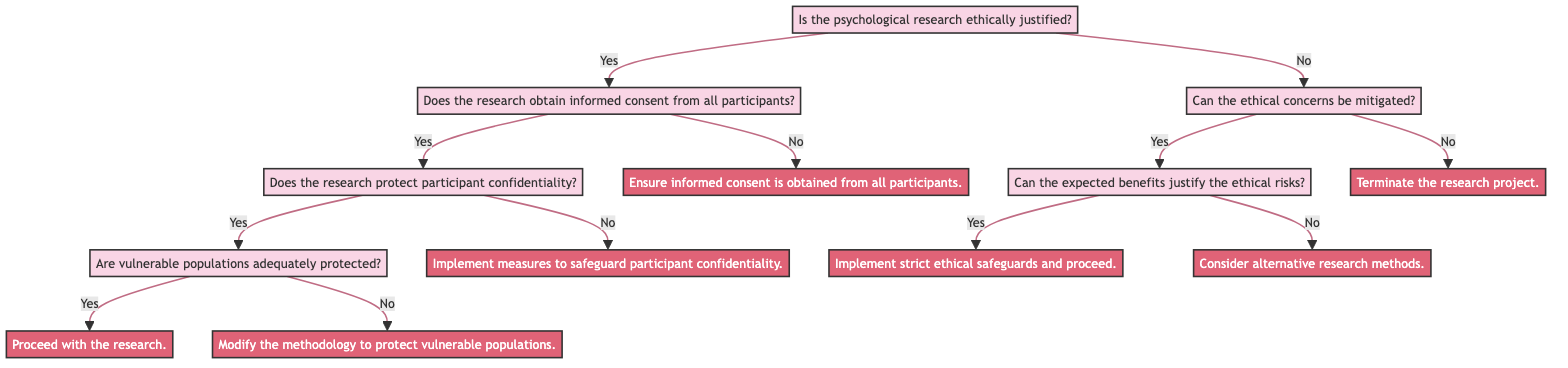Is the root question in the diagram about psychological research? The root question states, "Is the psychological research ethically justified?" This directly indicates that the main inquiry of the diagram is centered on the ethical justification of psychological research.
Answer: Yes What is the conclusion if the research obtains informed consent from all participants and protects participant confidentiality? If both conditions of obtaining informed consent and protecting confidentiality are met, the next question pertains to whether vulnerable populations are adequately protected. If yes, we conclude with "Proceed with the research."
Answer: Proceed with the research How many nodes are present in the diagram? The diagram consists of 13 nodes in total, including the root question, intermediate questions, and the final conclusions. This includes both questions and conclusions in the defined structure.
Answer: 13 What happens if ethical concerns cannot be mitigated? If the ethical concerns cannot be mitigated, the flow leads directly to the conclusion, "Terminate the research project." indicating the action to take under those circumstances.
Answer: Terminate the research project What are the implications if the expected benefits do not justify the ethical risks? If the expected benefits do not justify the ethical risks, the conclusion indicates that researchers should "Consider alternative research methods." This emphasizes the need for exploring other methodologies if ethical concerns prevail.
Answer: Consider alternative research methods What is the flow direction after the root question if the answer is "No"? If the answer to the root question is "No," the flow moves directly to the question, "Can the ethical concerns be mitigated?" This indicates a branching path towards addressing ethical concerns instead of proceeding with the research.
Answer: Can the ethical concerns be mitigated? If participant confidentiality is not protected, what should be implemented? In the case where participant confidentiality is compromised, the diagram indicates that measures should be implemented to safeguard participant confidentiality as a necessary step to address the ethical issue.
Answer: Implement measures to safeguard participant confidentiality What is the conclusion if vulnerable populations are not adequately protected? If vulnerable populations are inadequately protected, the conclusion states, "Modify the methodology to protect vulnerable populations," suggesting a need to alter the approach to ensure their protection.
Answer: Modify the methodology to protect vulnerable populations What question follows after confirming that the research is ethically justified? After confirming ethical justification, the next question is "Does the research obtain informed consent from all participants?" This question is crucial in assessing the next step in the ethical decision-making process.
Answer: Does the research obtain informed consent from all participants? 